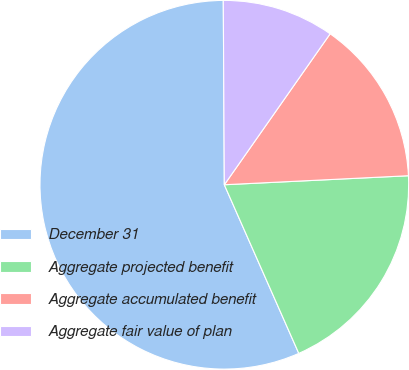Convert chart to OTSL. <chart><loc_0><loc_0><loc_500><loc_500><pie_chart><fcel>December 31<fcel>Aggregate projected benefit<fcel>Aggregate accumulated benefit<fcel>Aggregate fair value of plan<nl><fcel>56.53%<fcel>19.16%<fcel>14.49%<fcel>9.82%<nl></chart> 